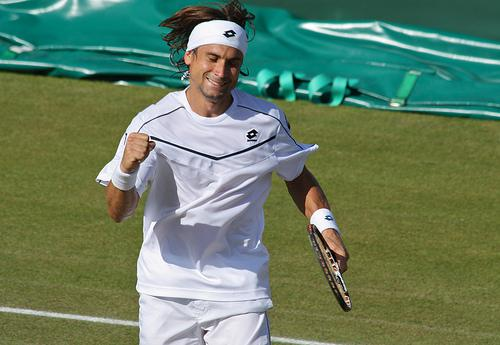Question: how many people are in the image?
Choices:
A. Two.
B. Three.
C. Five.
D. One.
Answer with the letter. Answer: D Question: what sport is this person playing?
Choices:
A. Basketball.
B. Football.
C. Tennis.
D. Soccer.
Answer with the letter. Answer: C Question: what color is the grass in the image?
Choices:
A. Brown.
B. Green.
C. Grey.
D. Blue.
Answer with the letter. Answer: B Question: how many wristbands is the person wearing?
Choices:
A. One.
B. Two.
C. Three.
D. Five.
Answer with the letter. Answer: B 